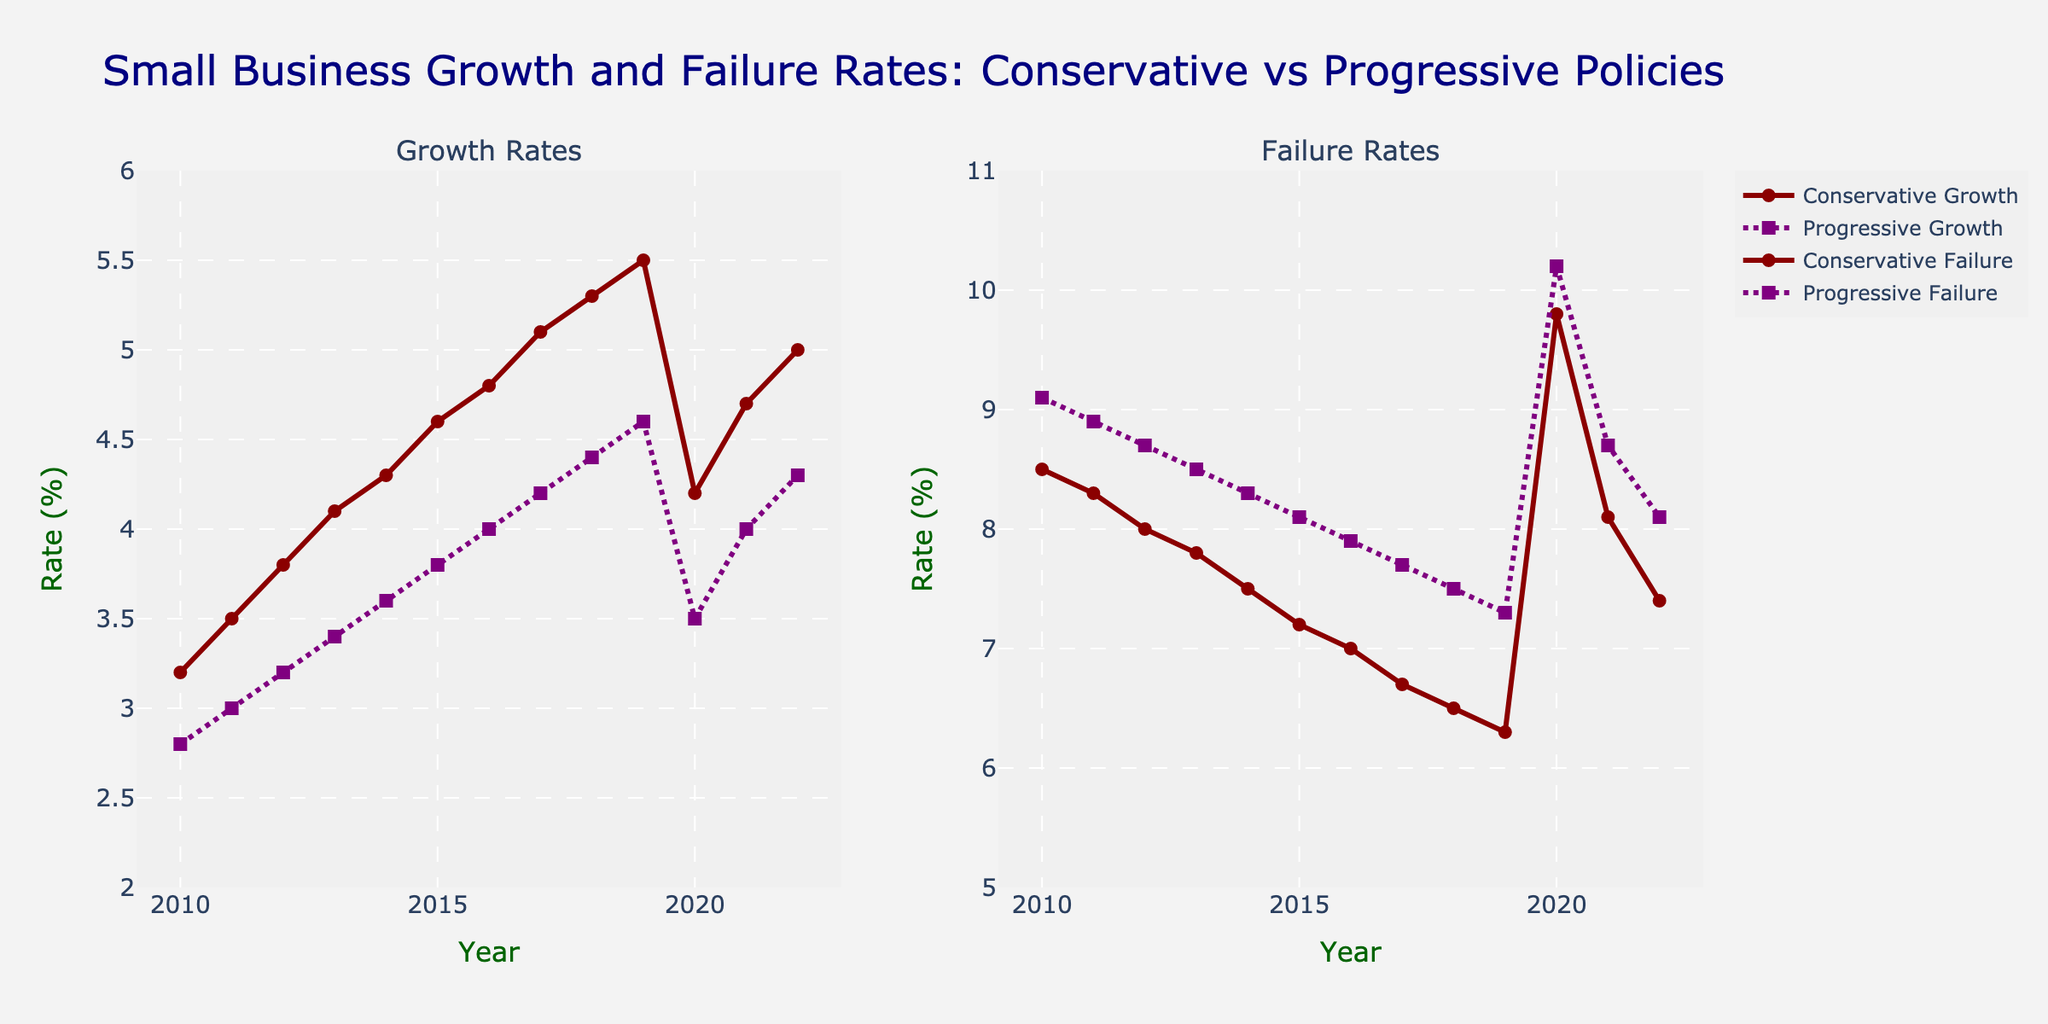What's the trend in Conservative Policy Growth Rate from 2010 to 2022? The Conservative Policy Growth Rate starts at 3.2% in 2010 and generally increases over time, reaching 5.0% in 2022. There is a slight dip in 2020 when it goes down to 4.2%, but it rises again afterward.
Answer: Increasing with a small dip in 2020 How did the Conservative Policy Failure Rate change between 2019 and 2021? The Conservative Policy Failure Rate rose sharply from 6.3% in 2019 to 9.8% in 2020, and then decreased to 8.1% in 2021.
Answer: Rose then fell Which year saw the highest difference in Growth Rate between Conservative and Progressive Policies? The difference is highest in 2019, with Conservative Policy Growth Rate at 5.5% and Progressive Policy Growth Rate at 4.6%, giving a difference of 0.9%.
Answer: 2019 How do the Conservative and Progressive Policies' Failure Rates compare in 2020? In 2020, the Conservative Policy Failure Rate is 9.8%, while the Progressive Policy Failure Rate is slightly higher at 10.2%.
Answer: Progressive is higher What is the average Growth Rate for Conservative Policies between 2010 and 2022? Sum the growth rates from 2010 (3.2%), 2011 (3.5%), 2012 (3.8%), 2013 (4.1%), 2014 (4.3%), 2015 (4.6%), 2016 (4.8%), 2017 (5.1%), 2018 (5.3%), 2019 (5.5%), 2020 (4.2%), 2021 (4.7%), 2022 (5.0%) and divide by 13. The sum is 57.1%, so the average is 57.1/13 ≈ 4.39%.
Answer: 4.39% Which policy had a steadier decline in Failure Rates from 2010 to 2019? The Conservative Policy Failure Rate shows a continuous and relatively steady decline from 8.5% in 2010 to 6.3% in 2019. In contrast, the Progressive Policy Failure Rate decreases less steadily from 9.1% in 2010 to 7.3% in 2019.
Answer: Conservative What is the trend in Progressive Policy Growth Rate between 2010 and 2019? The Progressive Policy Growth Rate starts at 2.8% in 2010 and gradually increases to 4.6% in 2019.
Answer: Increasing What is the biggest drop in Failure Rates for Conservative Policies and when did it happen? The biggest drop occurs between 2019 and 2020, where the Failure Rate drops from 6.3% to 9.8%, resulting in a 3.5% decrease.
Answer: 2019 to 2020 